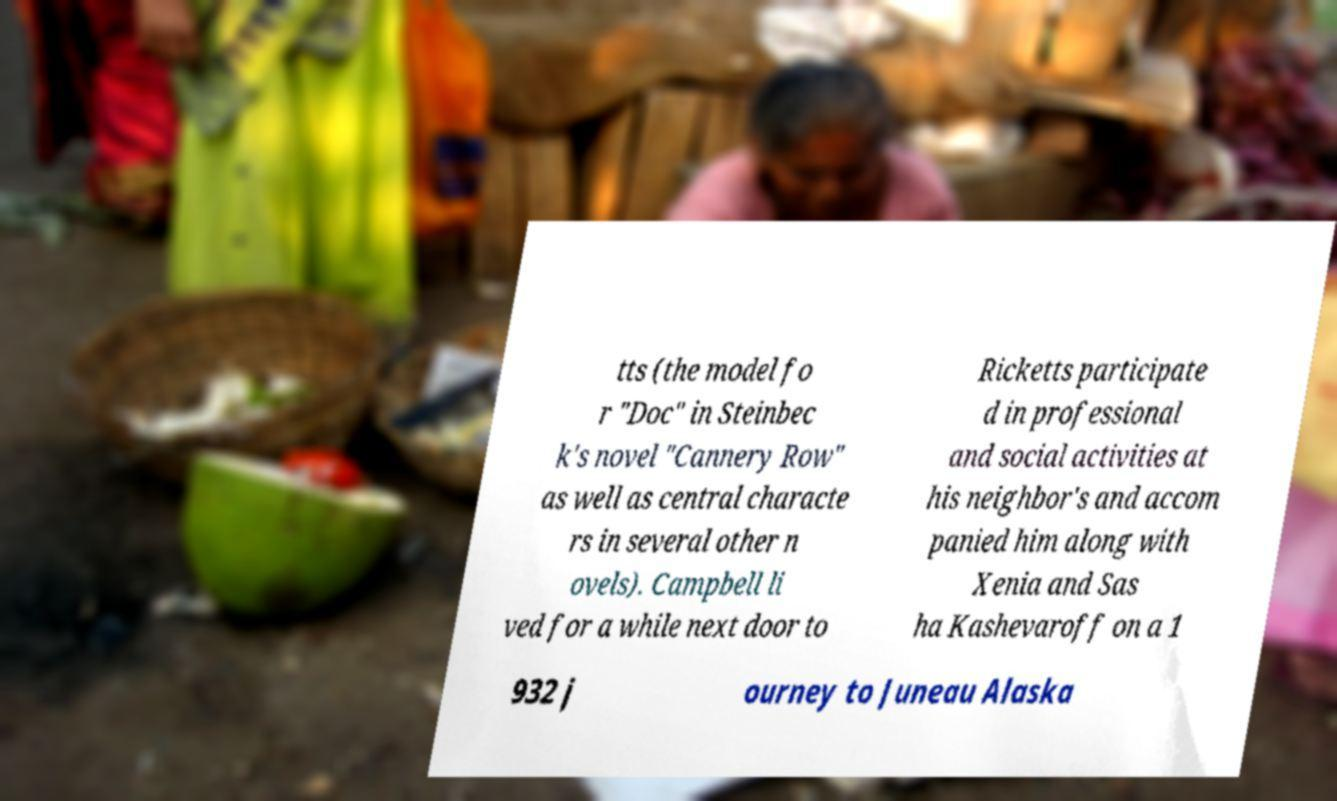Can you accurately transcribe the text from the provided image for me? tts (the model fo r "Doc" in Steinbec k's novel "Cannery Row" as well as central characte rs in several other n ovels). Campbell li ved for a while next door to Ricketts participate d in professional and social activities at his neighbor's and accom panied him along with Xenia and Sas ha Kashevaroff on a 1 932 j ourney to Juneau Alaska 